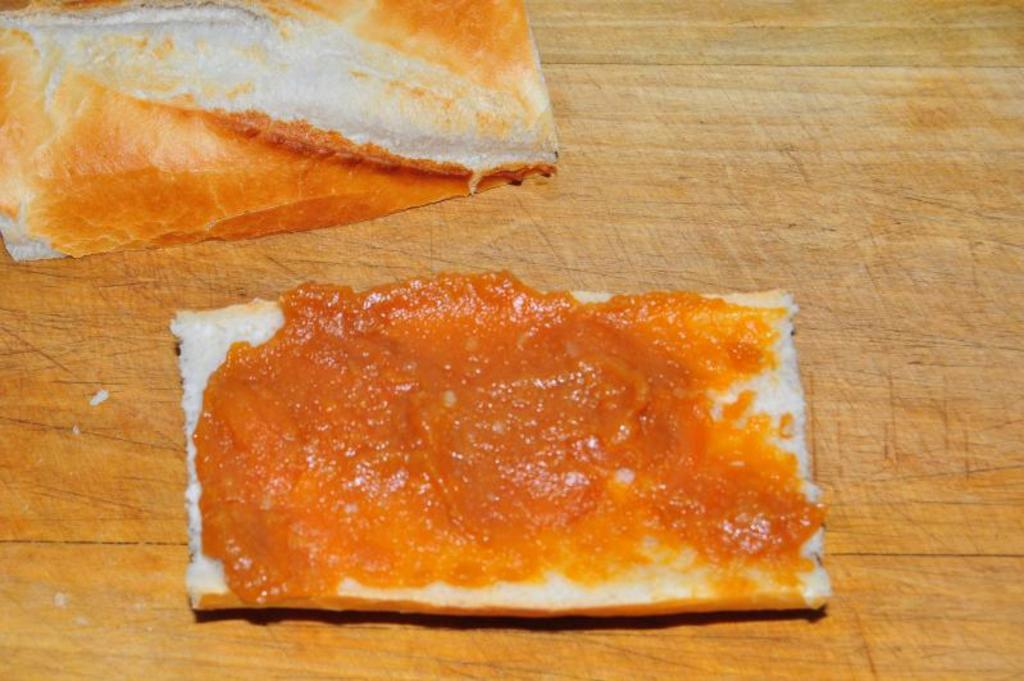What is the main subject of the image? The image is a zoomed-in view of a food item. Can you describe the surface on which the food item is placed? The food item is present on a wooden surface. What type of sponge is being used by the minister in the image? There is no sponge or minister present in the image; it is a zoomed-in view of a food item on a wooden surface. 